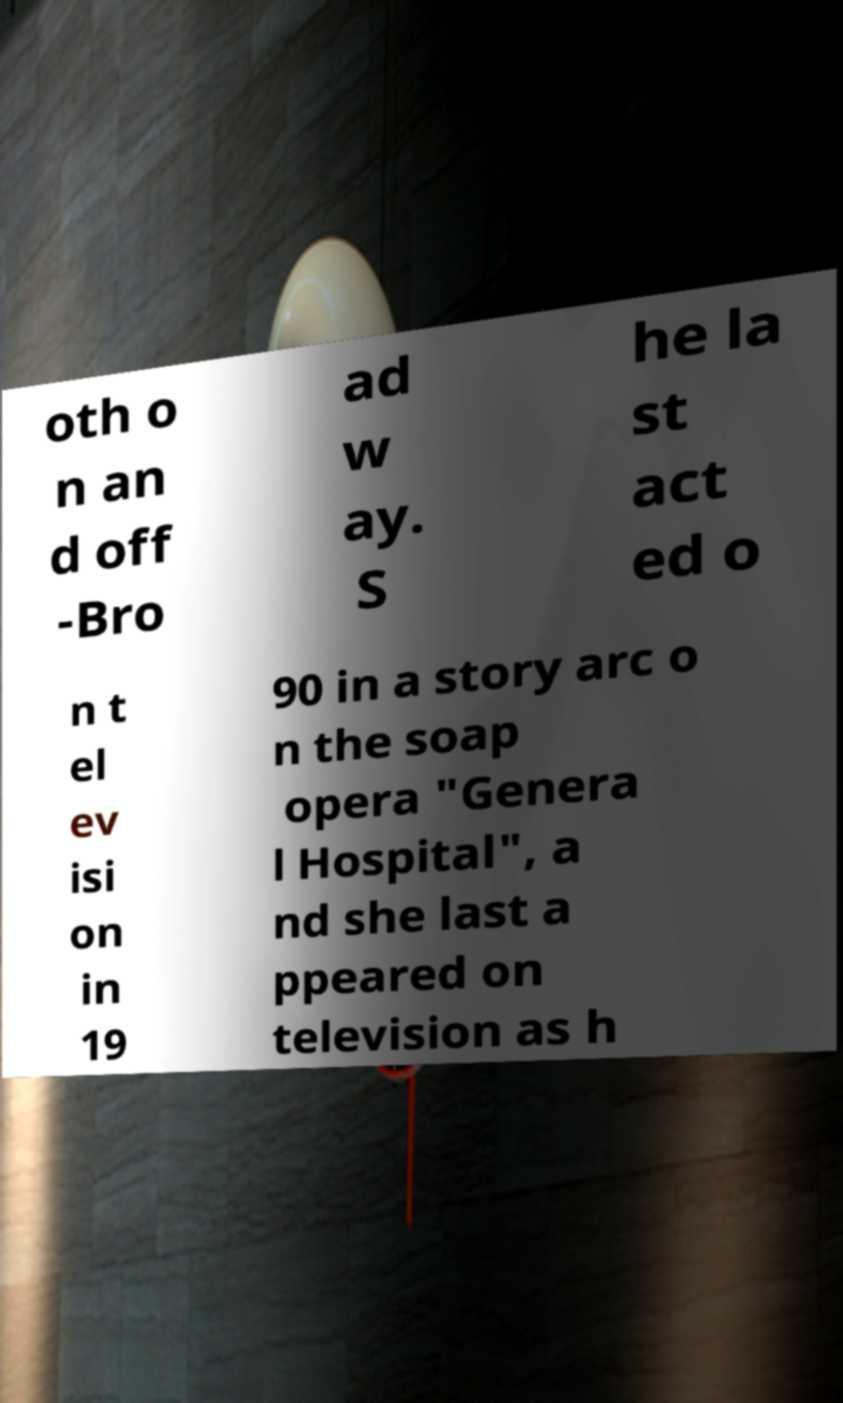Please identify and transcribe the text found in this image. oth o n an d off -Bro ad w ay. S he la st act ed o n t el ev isi on in 19 90 in a story arc o n the soap opera "Genera l Hospital", a nd she last a ppeared on television as h 